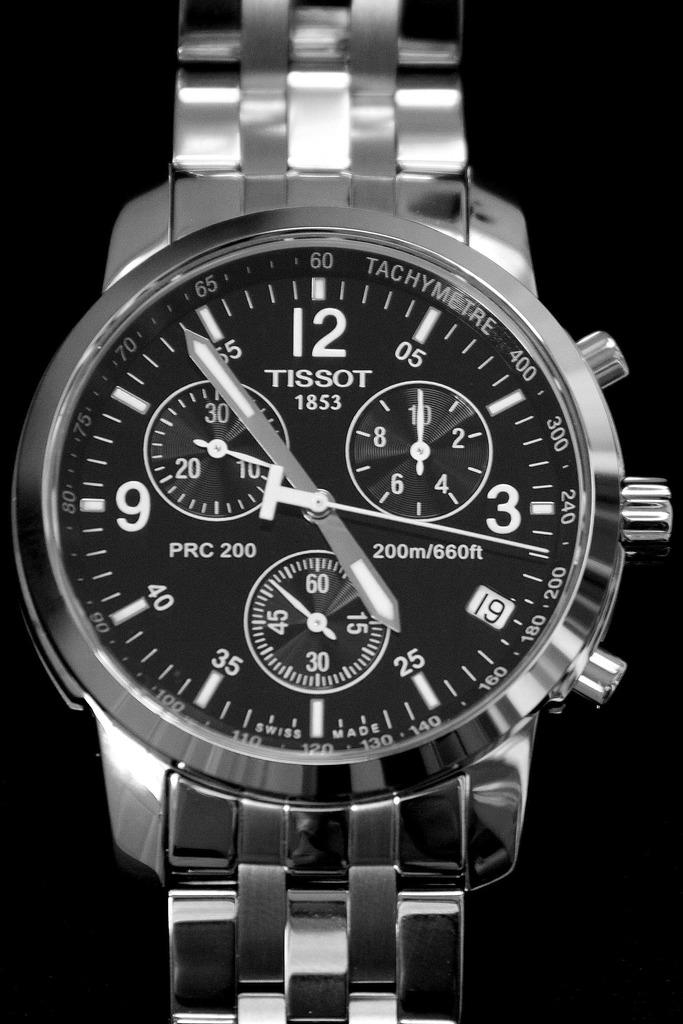<image>
Offer a succinct explanation of the picture presented. A Tissot brand watch has the year 1853 on the face. 